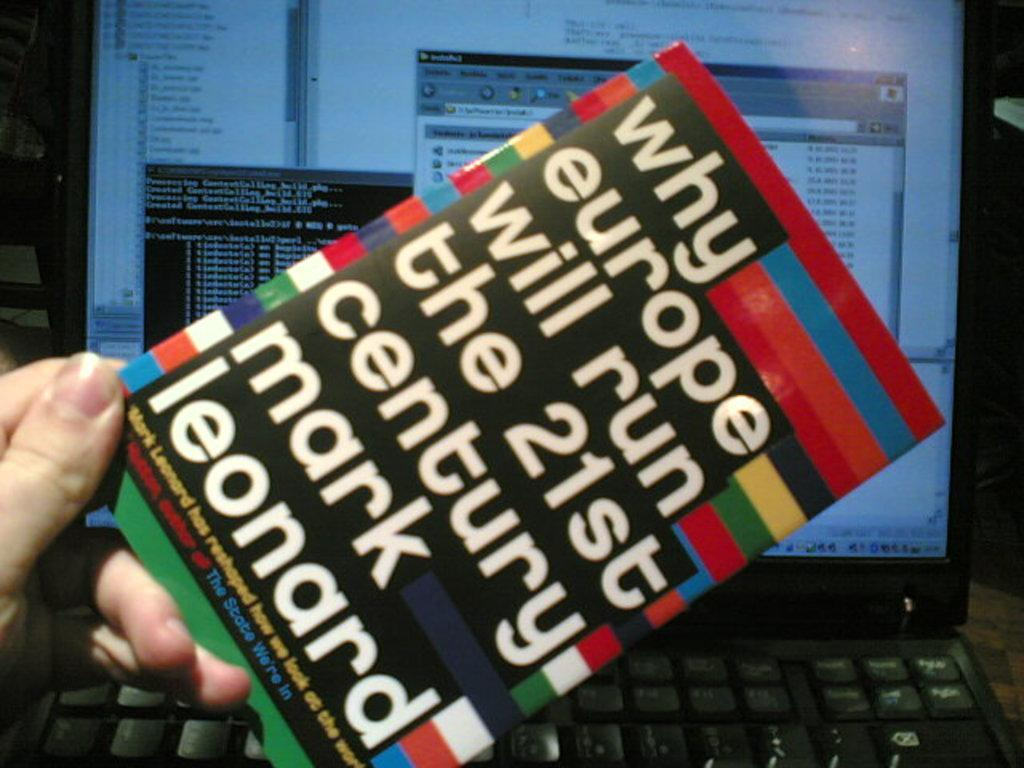<image>
Relay a brief, clear account of the picture shown. A colorful book entitled "Why Europe will Run the 21st Century" by Mark Leonard 